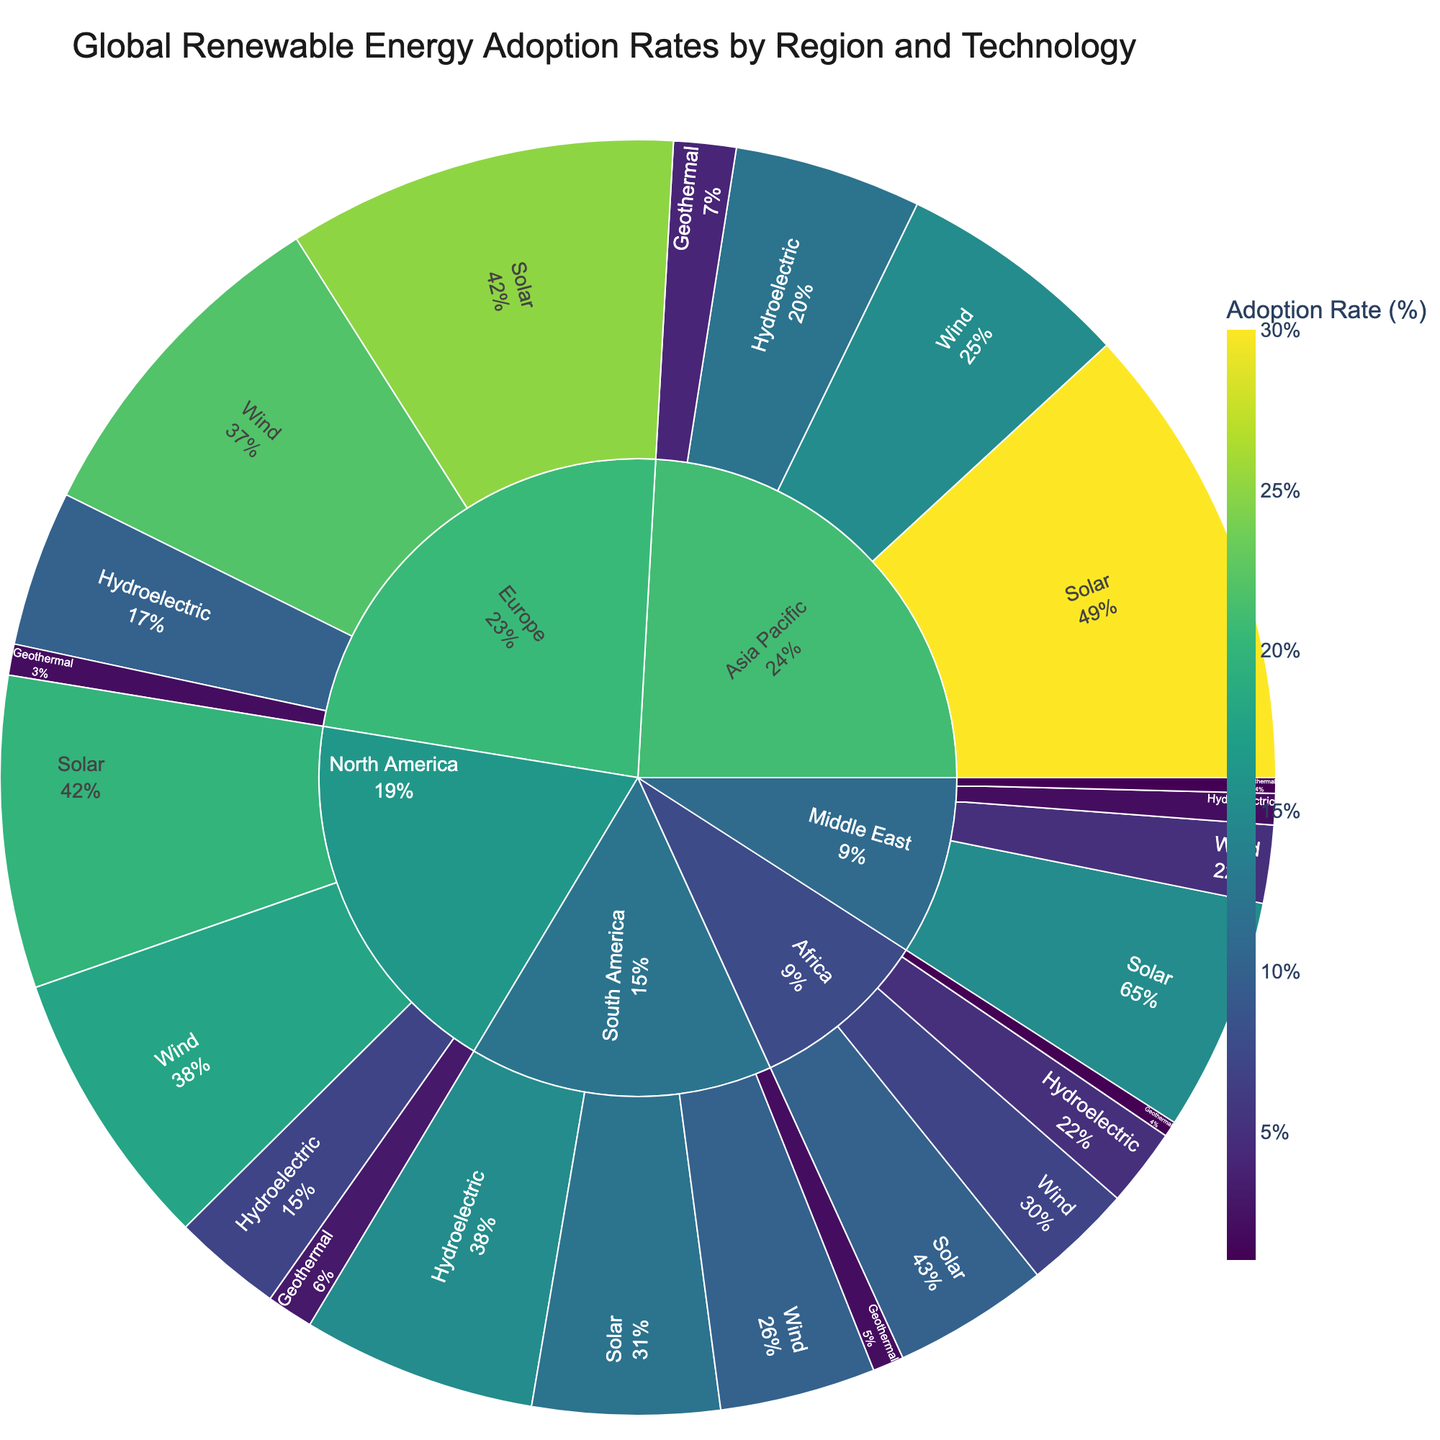What is the title of the figure? The title is typically located at the top of the figure; it is displayed prominently to describe the overall theme or subject of the chart.
Answer: Global Renewable Energy Adoption Rates by Region and Technology Which region has the highest adoption rate for solar energy? Focus on the 'Region' section and then look for the solar energy adoption rate within each region. The highest percentage will be the answer.
Answer: Asia Pacific What is the total adoption rate of all renewable technologies in Europe? Sum the adoption rates of all technologies (Solar, Wind, Hydroelectric, Geothermal) in Europe. 25 + 22 + 10 + 2 = 59
Answer: 59 How does the wind energy adoption rate in North America compare to that in Europe? Identify the rates for Wind energy in both North America (18) and Europe (22) and compare them directly.
Answer: Europe has a higher wind energy adoption rate Which region has the smallest adoption rate for geothermal energy? Look at all regions and compare the adoption rates for geothermal energy. The region with the smallest value will be the answer.
Answer: Middle East and Africa (both 1%) What proportion of global solar adoption is attributed to Asia Pacific? Calculate the sum of solar adoption rates across all regions: 15+20+25+30+10+12=112. Then, find the proportion of Asia Pacific's solar adoption rate to this total: 30/112.
Answer: Approximately 26.8% What technology type has the least variation in adoption rates across different regions? Compare the range of adoption rates (maximum - minimum) for each technology across all regions, and the technology with the smallest range shows the least variation.
Answer: Geothermal Which region shows the greatest diversity in renewable technology adoption rates? Evaluate the spread or range of adoption rates across different technologies within each region. The greatest range (difference between the highest and lowest rates) will indicate the greatest diversity.
Answer: Europe Combining solar and wind, which region leads in adoption rates? Sum the solar and wind adoption rates for each region and determine the highest combined value. For example, for Europe: 25 (Solar) + 22 (Wind) = 47
Answer: Europe Considering all technologies, which region has the overall lowest adoption rate? Sum the adoption rates of all technologies for each region. Identify the region with the lowest total adoption. For example, for Africa: 10 (Solar) + 7 (Wind) + 5 (Hydroelectric) + 1 (Geothermal) = 23
Answer: Middle East 